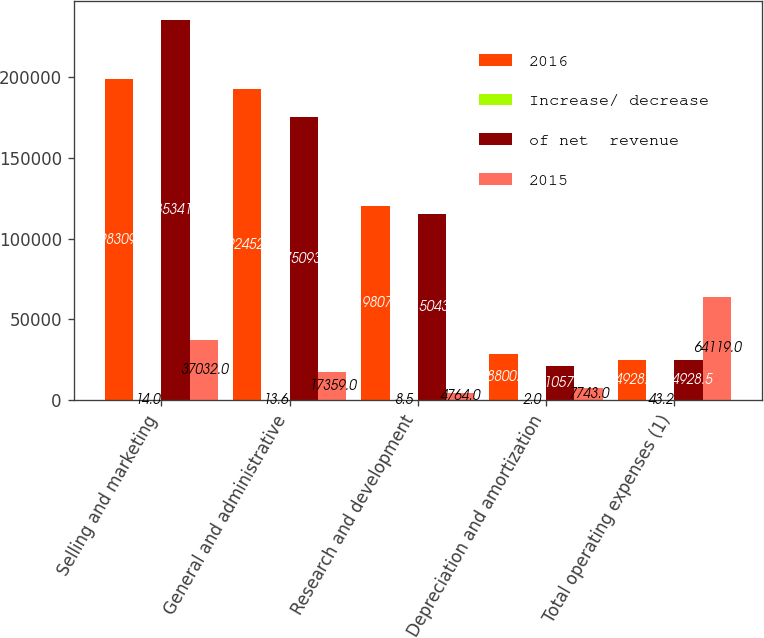Convert chart to OTSL. <chart><loc_0><loc_0><loc_500><loc_500><stacked_bar_chart><ecel><fcel>Selling and marketing<fcel>General and administrative<fcel>Research and development<fcel>Depreciation and amortization<fcel>Total operating expenses (1)<nl><fcel>2016<fcel>198309<fcel>192452<fcel>119807<fcel>28800<fcel>24928.5<nl><fcel>Increase/ decrease<fcel>14<fcel>13.6<fcel>8.5<fcel>2<fcel>43.2<nl><fcel>of net  revenue<fcel>235341<fcel>175093<fcel>115043<fcel>21057<fcel>24928.5<nl><fcel>2015<fcel>37032<fcel>17359<fcel>4764<fcel>7743<fcel>64119<nl></chart> 